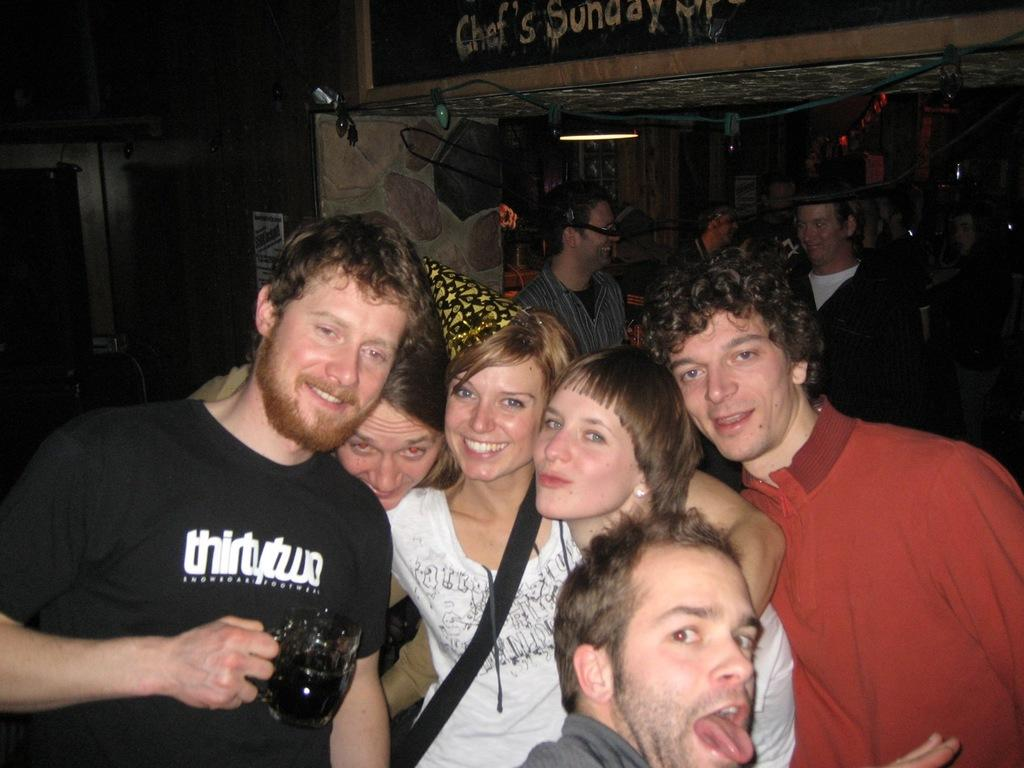<image>
Render a clear and concise summary of the photo. The guy has the number 32 spelled out on his shirt. 